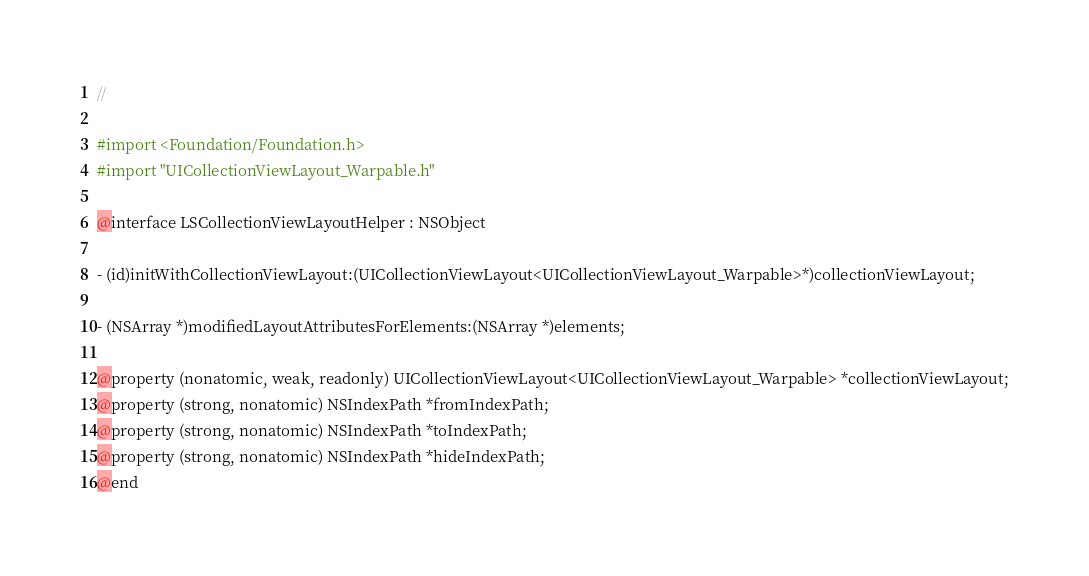Convert code to text. <code><loc_0><loc_0><loc_500><loc_500><_C_>//

#import <Foundation/Foundation.h>
#import "UICollectionViewLayout_Warpable.h"

@interface LSCollectionViewLayoutHelper : NSObject

- (id)initWithCollectionViewLayout:(UICollectionViewLayout<UICollectionViewLayout_Warpable>*)collectionViewLayout;

- (NSArray *)modifiedLayoutAttributesForElements:(NSArray *)elements;

@property (nonatomic, weak, readonly) UICollectionViewLayout<UICollectionViewLayout_Warpable> *collectionViewLayout;
@property (strong, nonatomic) NSIndexPath *fromIndexPath;
@property (strong, nonatomic) NSIndexPath *toIndexPath;
@property (strong, nonatomic) NSIndexPath *hideIndexPath;
@end
</code> 